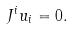Convert formula to latex. <formula><loc_0><loc_0><loc_500><loc_500>J ^ { i } u _ { i } = 0 .</formula> 